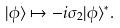<formula> <loc_0><loc_0><loc_500><loc_500>| \phi \rangle \mapsto - i \sigma _ { 2 } | \phi \rangle ^ { * } .</formula> 